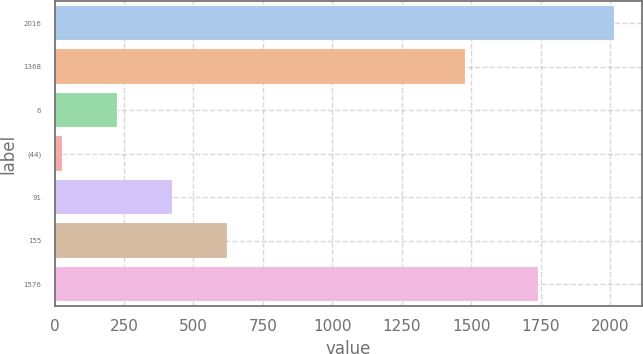Convert chart. <chart><loc_0><loc_0><loc_500><loc_500><bar_chart><fcel>2016<fcel>1368<fcel>6<fcel>(44)<fcel>91<fcel>155<fcel>1576<nl><fcel>2014<fcel>1479<fcel>223.9<fcel>25<fcel>422.8<fcel>621.7<fcel>1741<nl></chart> 